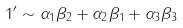Convert formula to latex. <formula><loc_0><loc_0><loc_500><loc_500>1 ^ { \prime } \sim \alpha _ { 1 } \beta _ { 2 } + \alpha _ { 2 } \beta _ { 1 } + \alpha _ { 3 } \beta _ { 3 }</formula> 